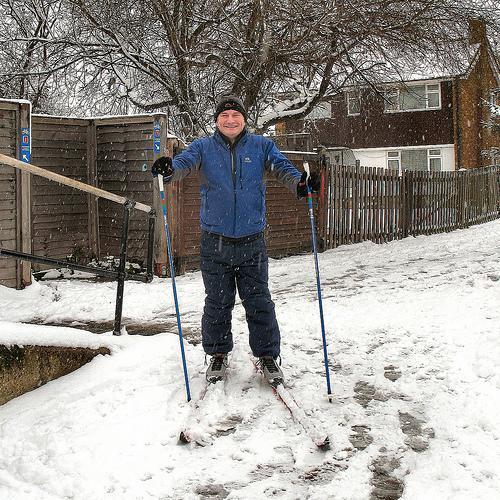How many people are in the photo?
Give a very brief answer. 1. 